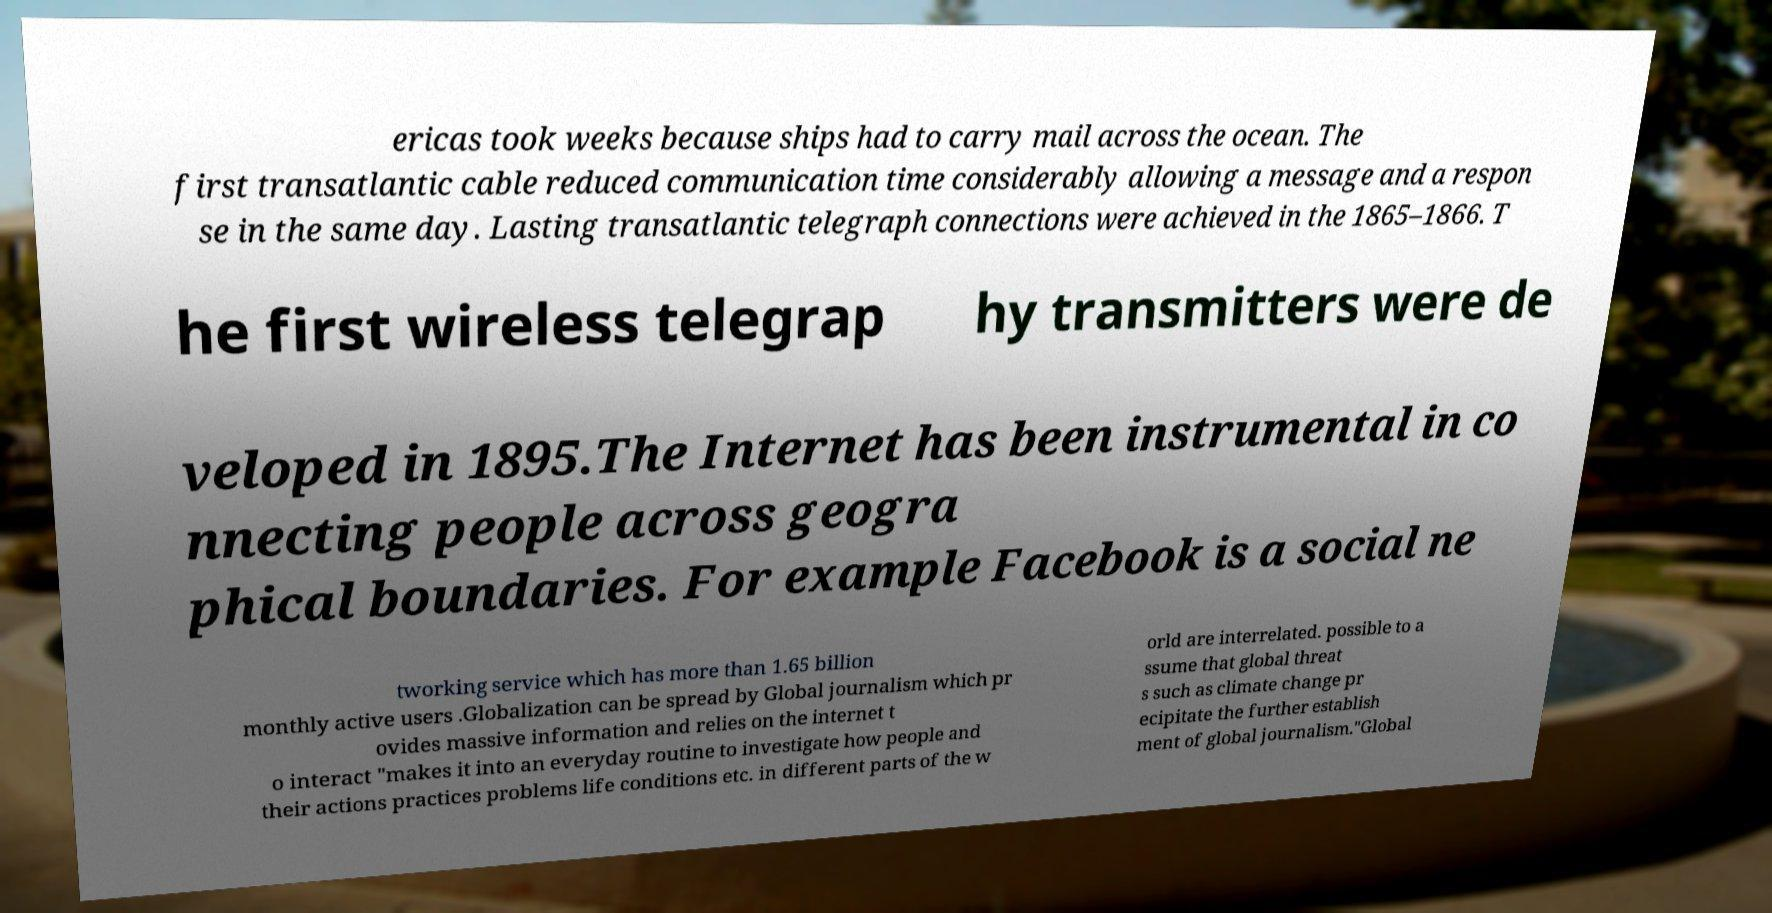Could you assist in decoding the text presented in this image and type it out clearly? ericas took weeks because ships had to carry mail across the ocean. The first transatlantic cable reduced communication time considerably allowing a message and a respon se in the same day. Lasting transatlantic telegraph connections were achieved in the 1865–1866. T he first wireless telegrap hy transmitters were de veloped in 1895.The Internet has been instrumental in co nnecting people across geogra phical boundaries. For example Facebook is a social ne tworking service which has more than 1.65 billion monthly active users .Globalization can be spread by Global journalism which pr ovides massive information and relies on the internet t o interact "makes it into an everyday routine to investigate how people and their actions practices problems life conditions etc. in different parts of the w orld are interrelated. possible to a ssume that global threat s such as climate change pr ecipitate the further establish ment of global journalism."Global 